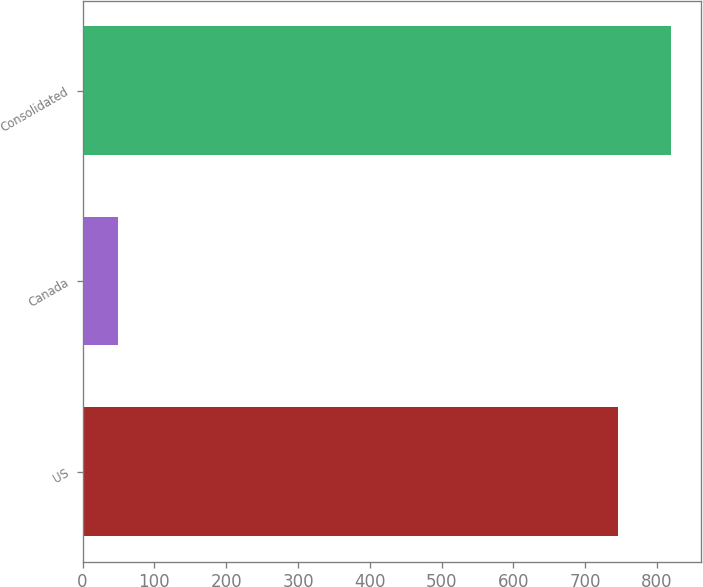<chart> <loc_0><loc_0><loc_500><loc_500><bar_chart><fcel>US<fcel>Canada<fcel>Consolidated<nl><fcel>745.2<fcel>48.6<fcel>819.72<nl></chart> 